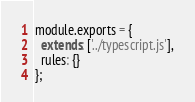Convert code to text. <code><loc_0><loc_0><loc_500><loc_500><_JavaScript_>module.exports = {
  extends: ['../typescript.js'],
  rules: {}
};
</code> 